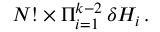Convert formula to latex. <formula><loc_0><loc_0><loc_500><loc_500>N ! \times \Pi _ { i = 1 } ^ { k - 2 } \, \delta H _ { i } \, .</formula> 